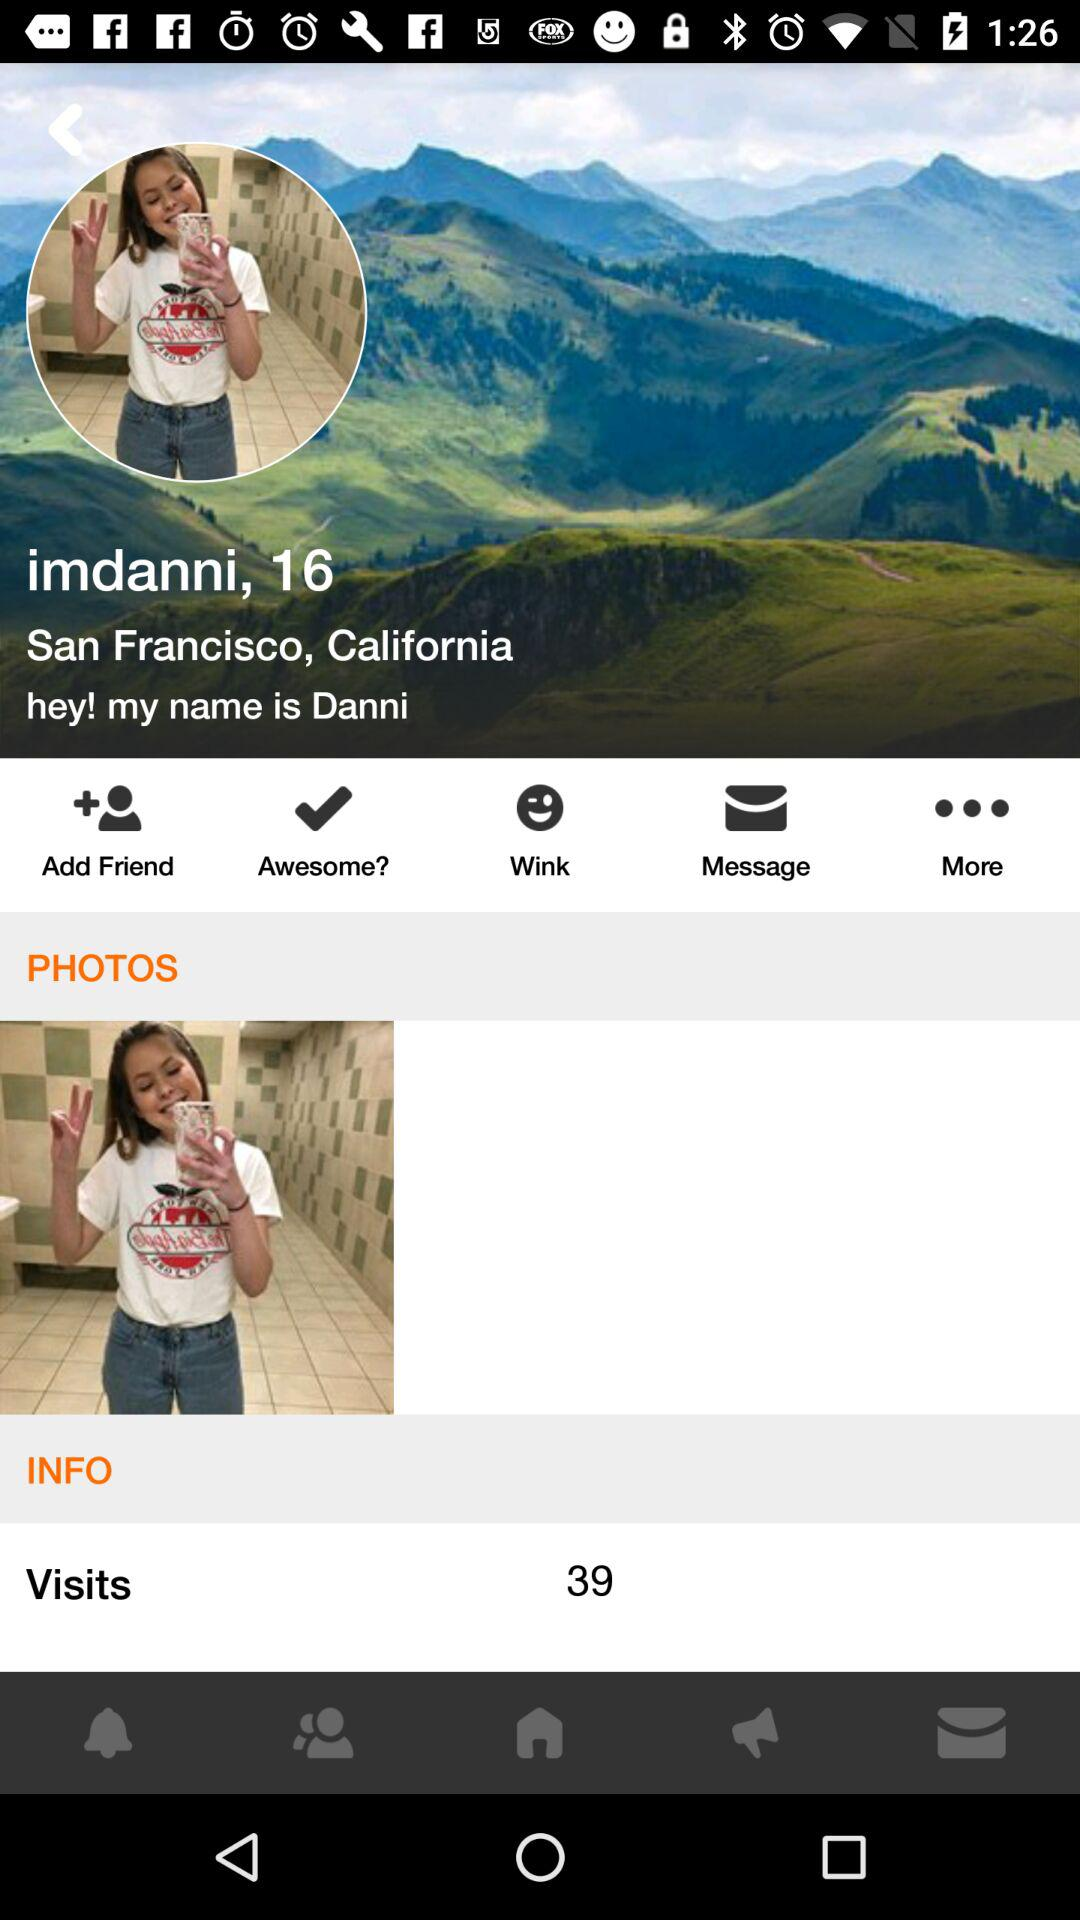What is the user name? The user name is Danni. 